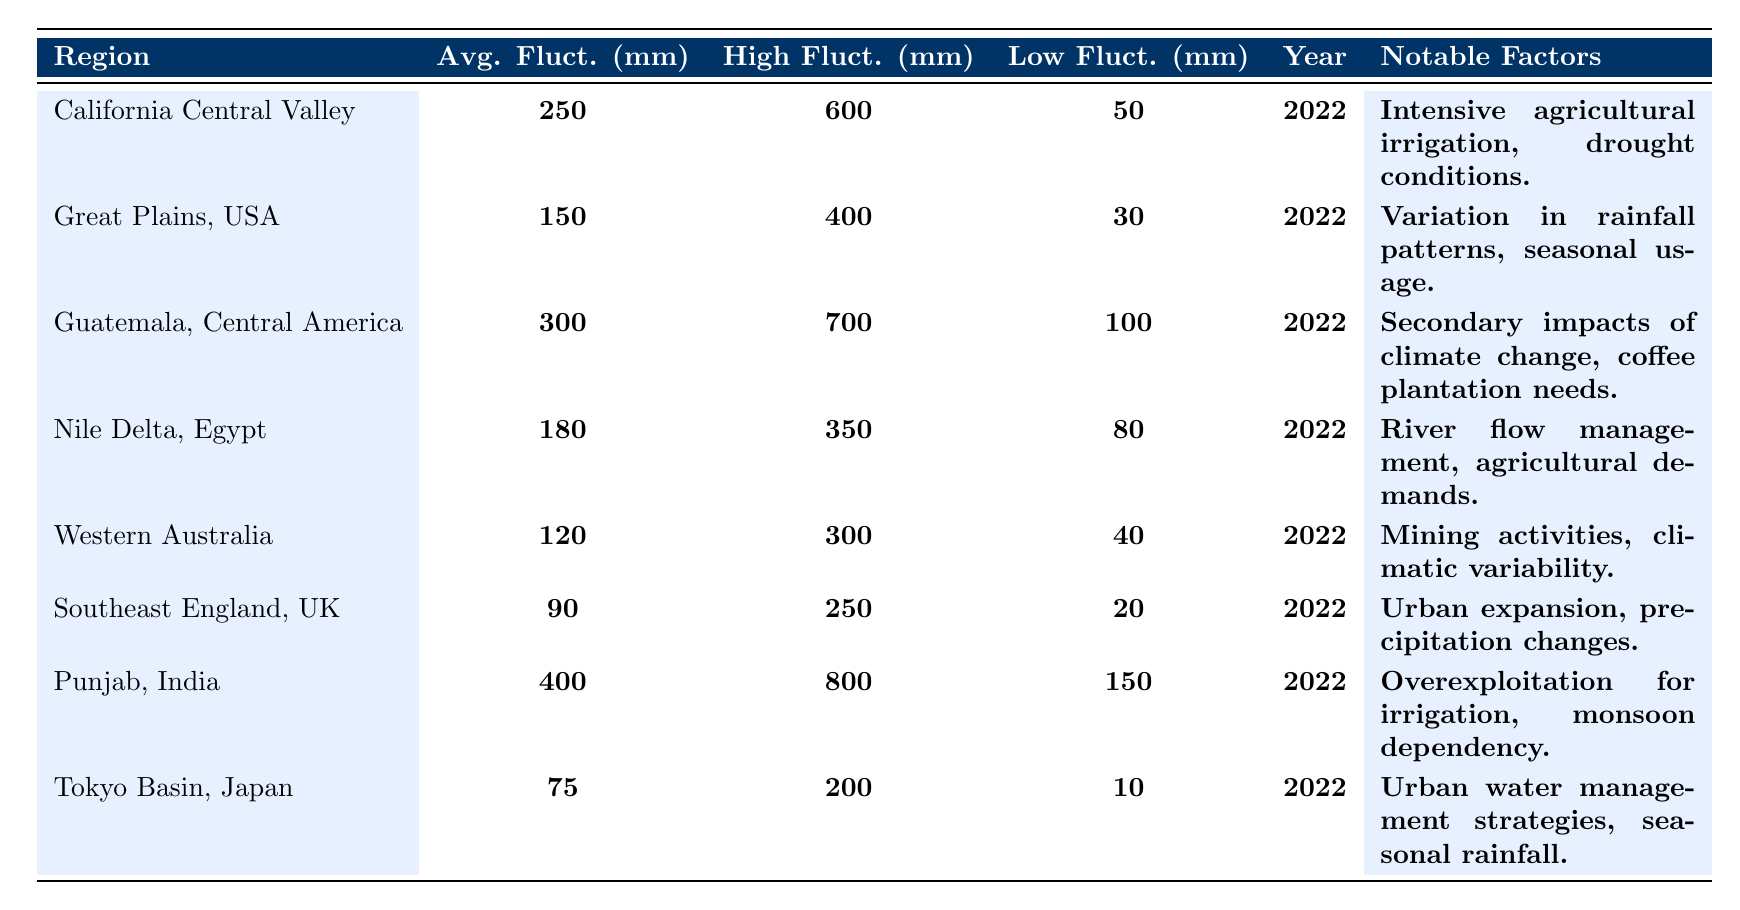What is the average fluctuation in the Punjab region? The table indicates that the average fluctuation in the Punjab region is listed as 400 mm.
Answer: 400 mm Which region experienced the highest fluctuation recorded, and what was its value? The region with the highest fluctuation is Punjab, with a value of 800 mm, as shown in the table.
Answer: Punjab, 800 mm What is the lowest fluctuation reported for the Great Plains, USA? According to the table, the lowest fluctuation reported for the Great Plains, USA, is 30 mm.
Answer: 30 mm Is the average fluctuation in the Tokyo Basin higher than that in Southeast England? The average fluctuation for Tokyo Basin is 75 mm, while for Southeast England, it is 90 mm. Since 75 mm is less than 90 mm, the statement is false.
Answer: No Which region has the lowest average fluctuation, and what are its notable factors? The region with the lowest average fluctuation is Southeast England, which has an average of 90 mm. Its notable factors include urban expansion and precipitation changes.
Answer: Southeast England, urban expansion and precipitation changes What is the range of fluctuations in Guatemala, Central America? The range is calculated as the highest fluctuation minus the lowest fluctuation: 700 mm (highest) - 100 mm (lowest) = 600 mm.
Answer: 600 mm Are the notable factors for California Central Valley directly related to agricultural activities? Yes, the notable factors mention intensive agricultural irrigation and drought conditions, indicating a direct relationship with agricultural activities.
Answer: Yes If we compare the average fluctuations of California Central Valley and Nile Delta, which region has a higher average? California Central Valley has an average fluctuation of 250 mm, while the Nile Delta has an average of 180 mm. Since 250 mm is greater than 180 mm, California Central Valley has a higher average.
Answer: California Central Valley What notable factor contributes to the water table fluctuations in Western Australia? The notable factor listed for Western Australia is mining activities coupled with climatic variability, as seen in the table.
Answer: Mining activities and climatic variability Calculate the total of the average fluctuations from the regions listed in the table. The average fluctuations are: 250 (California) + 150 (Great Plains) + 300 (Guatemala) + 180 (Nile Delta) + 120 (Western Australia) + 90 (Southeast England) + 400 (Punjab) + 75 (Tokyo Basin) = 1565 mm total.
Answer: 1565 mm 